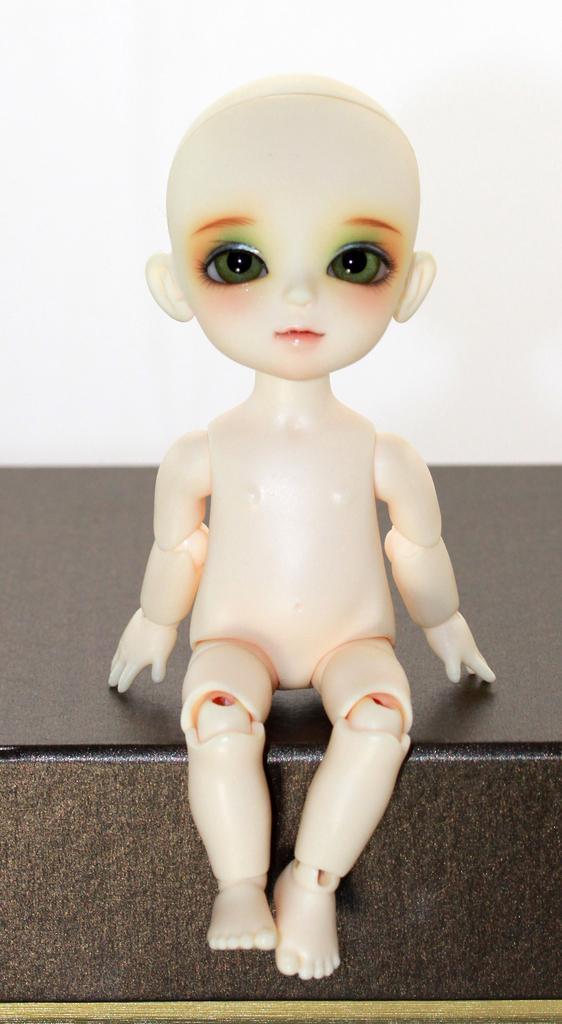In one or two sentences, can you explain what this image depicts? It is a doll in white color. 